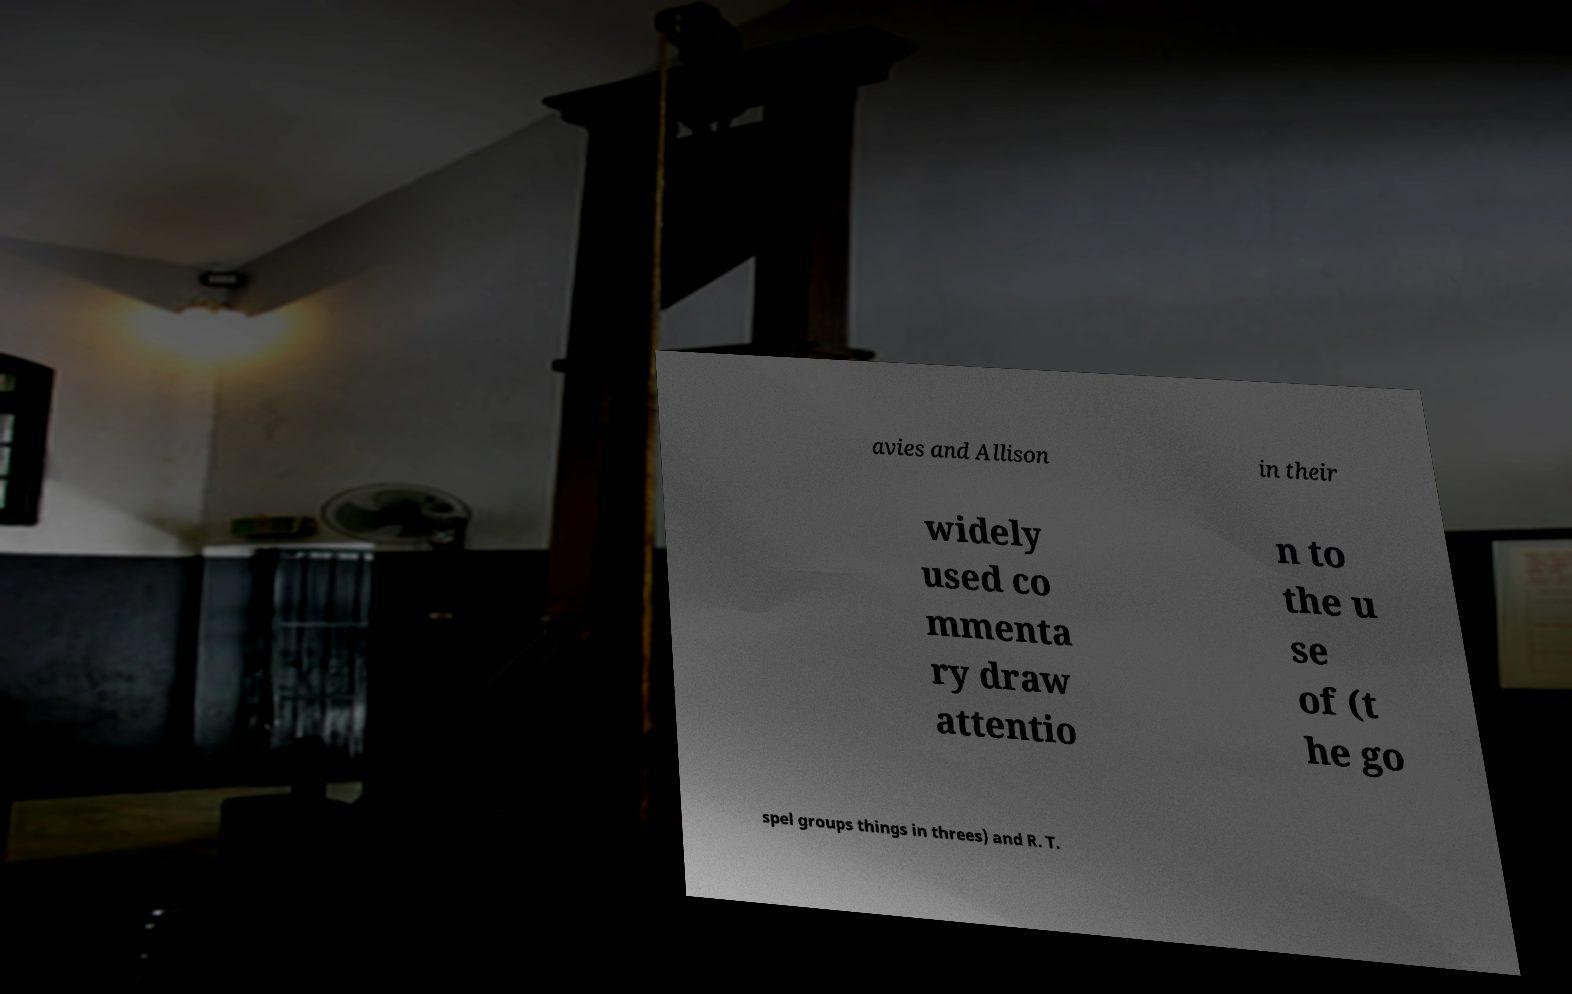Can you accurately transcribe the text from the provided image for me? avies and Allison in their widely used co mmenta ry draw attentio n to the u se of (t he go spel groups things in threes) and R. T. 